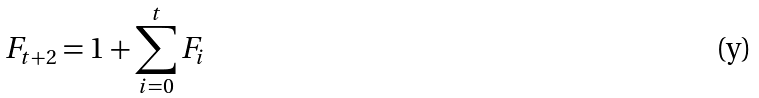<formula> <loc_0><loc_0><loc_500><loc_500>F _ { t + 2 } = 1 + \sum _ { i = 0 } ^ { t } F _ { i }</formula> 